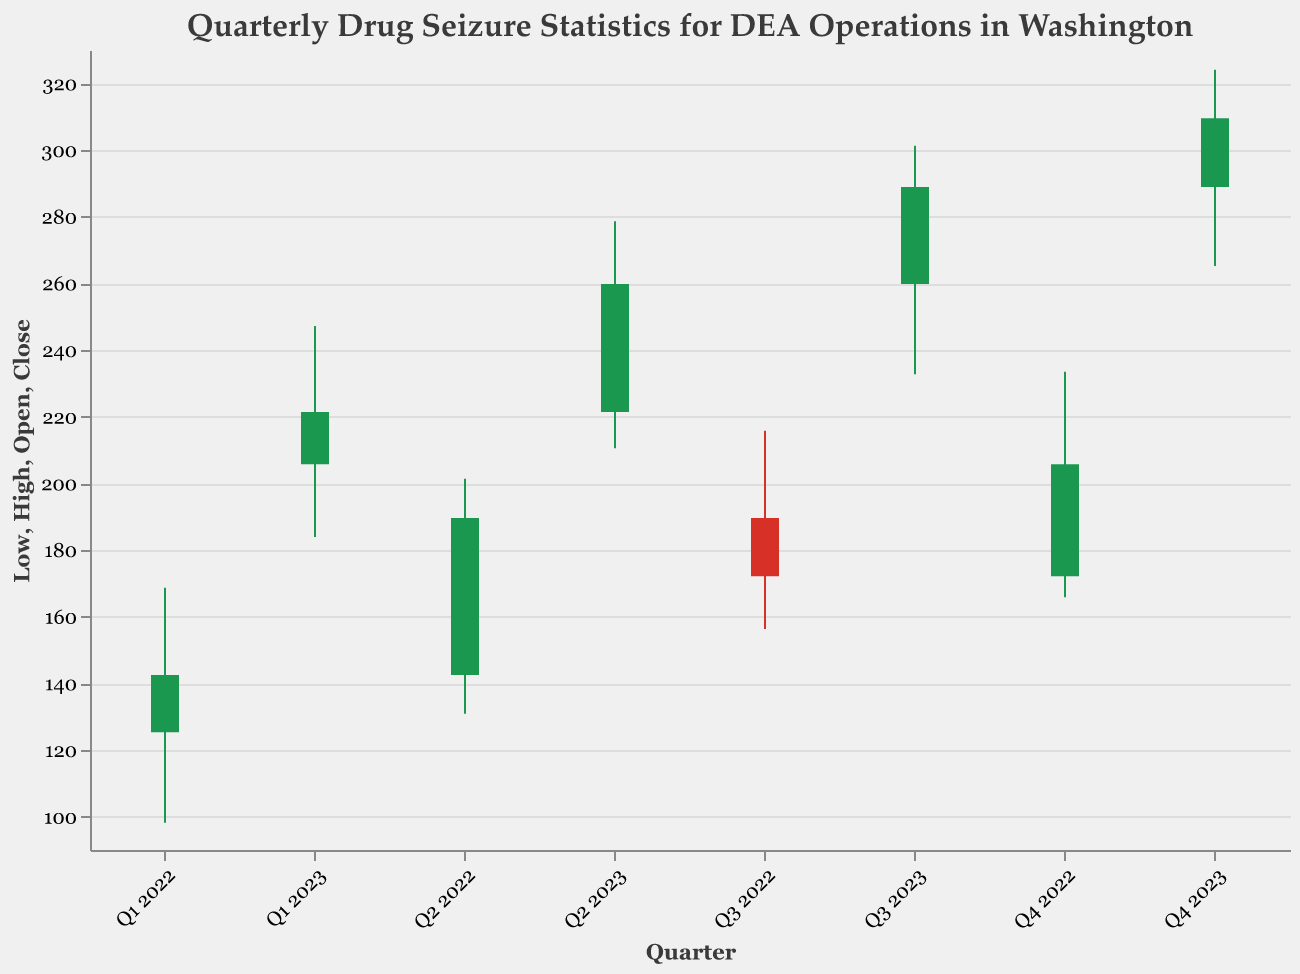What is the title of the chart? The title of the chart is given at the top of the visual representation.
Answer: Quarterly Drug Seizure Statistics for DEA Operations in Washington What is the highest drug seizure value recorded in 2022? In the chart, the highest value for 2022 is the 'High' value in Q4 2022.
Answer: 233.5 Which quarter had the lowest drug seizure value in 2023? The lowest value for 2023 is found by looking at the 'Low' values for each quarter in 2023. The quarter with the lowest value is Q1 2023.
Answer: Q1 2023 How did the figures close compare from Q3 2023 to Q4 2023? To answer, compare the 'Close' values for Q3 2023 and Q4 2023. Q3's Close is 288.9, and Q4's Close is 309.5.
Answer: Increased Between which quarters in 2022 did the drug seizure quantities decrease? Check the 'Close' values for consecutive quarters in 2022. The decrease happens between Q3 2022 (172.1) and Q4 2022 (205.7).
Answer: No decrease Calculate the average Close value for all quarters in 2022. Sum the 'Close' values for each quarter in 2022 and divide by the number of quarters: (142.5 + 189.6 + 172.1 + 205.7) / 4. The sum is 709.9, so the average is 709.9 / 4 = 177.475
Answer: 177.475 Which quarter showed the biggest difference between its High and Low values in 2023? Subtract the 'Low' value from the 'High' value for each quarter in 2023 and compare: Q1: 247.2 - 183.9 = 63.3, Q2: 278.6 - 210.5 = 68.1, Q3: 301.3 - 232.7 = 68.6, Q4: 324.1 - 265.2 = 58.9. The highest difference is in Q3 2023.
Answer: Q3 2023 Did Q2 2022 close higher or lower than it opened? Compare the 'Open' value (142.5) with the 'Close' value (189.6) for Q2 2022.
Answer: Higher From Q1 2022 to Q4 2023, did the overall trend of quarterly drug seizures increase or decrease? Look at the 'Close' values from Q1 2022 (142.5) to Q4 2023 (309.5). The overall trend is increasing.
Answer: Increase 